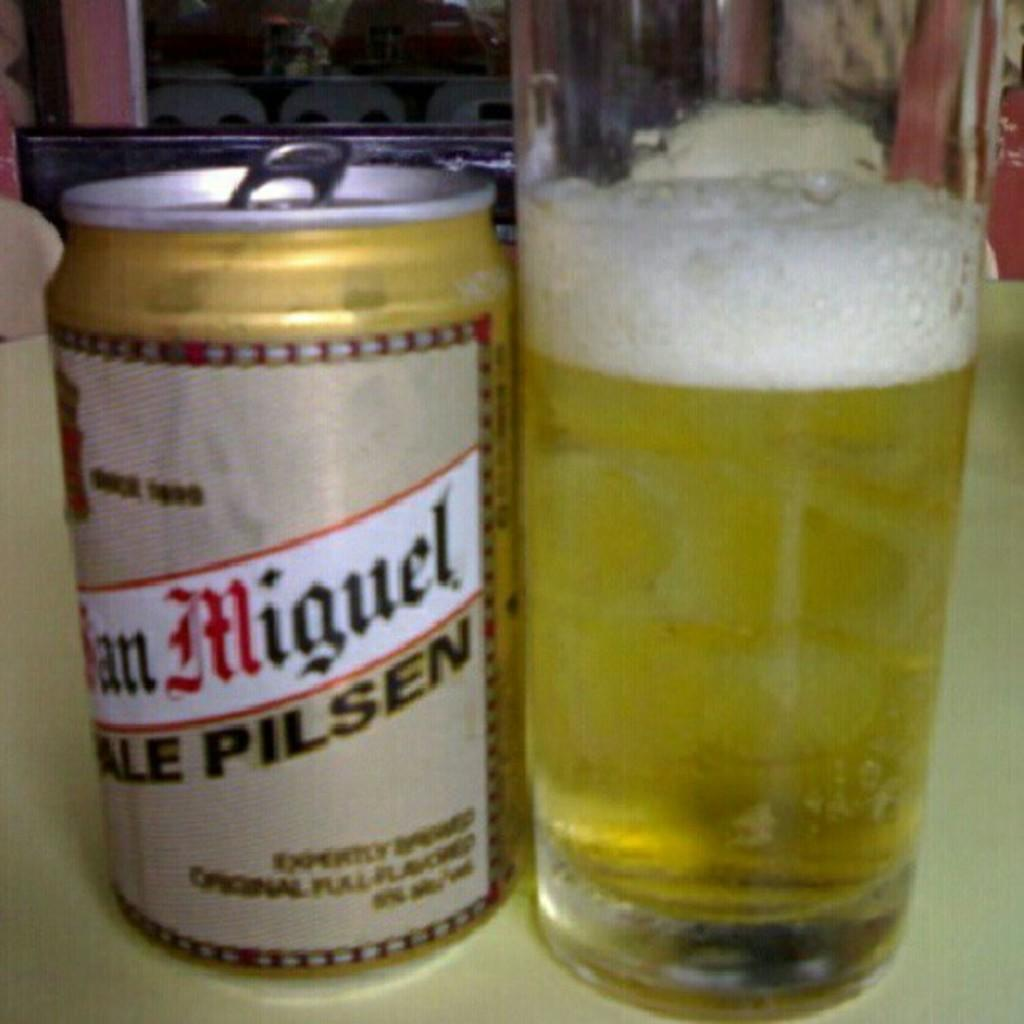<image>
Summarize the visual content of the image. A can of beer with the word "Miguel" on it sits near a glass of beer. 